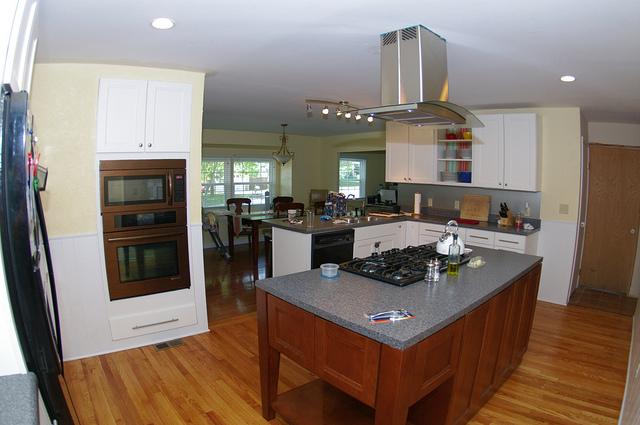Does the dining area have the same style floor as the rest of the kitchen?
Write a very short answer. Yes. Is this a modern kitchen?
Quick response, please. Yes. Is the floor laminate or real hardwood?
Short answer required. Laminate. What color is the dishwasher?
Give a very brief answer. Black. What's the table made of?
Concise answer only. Wood. Is the floor wood?
Concise answer only. Yes. What color are the countertops?
Be succinct. Gray. 